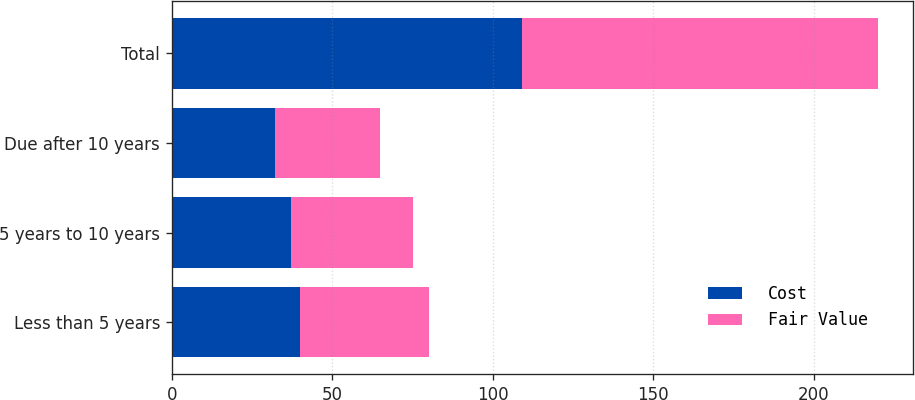Convert chart to OTSL. <chart><loc_0><loc_0><loc_500><loc_500><stacked_bar_chart><ecel><fcel>Less than 5 years<fcel>5 years to 10 years<fcel>Due after 10 years<fcel>Total<nl><fcel>Cost<fcel>40<fcel>37<fcel>32<fcel>109<nl><fcel>Fair Value<fcel>40<fcel>38<fcel>33<fcel>111<nl></chart> 